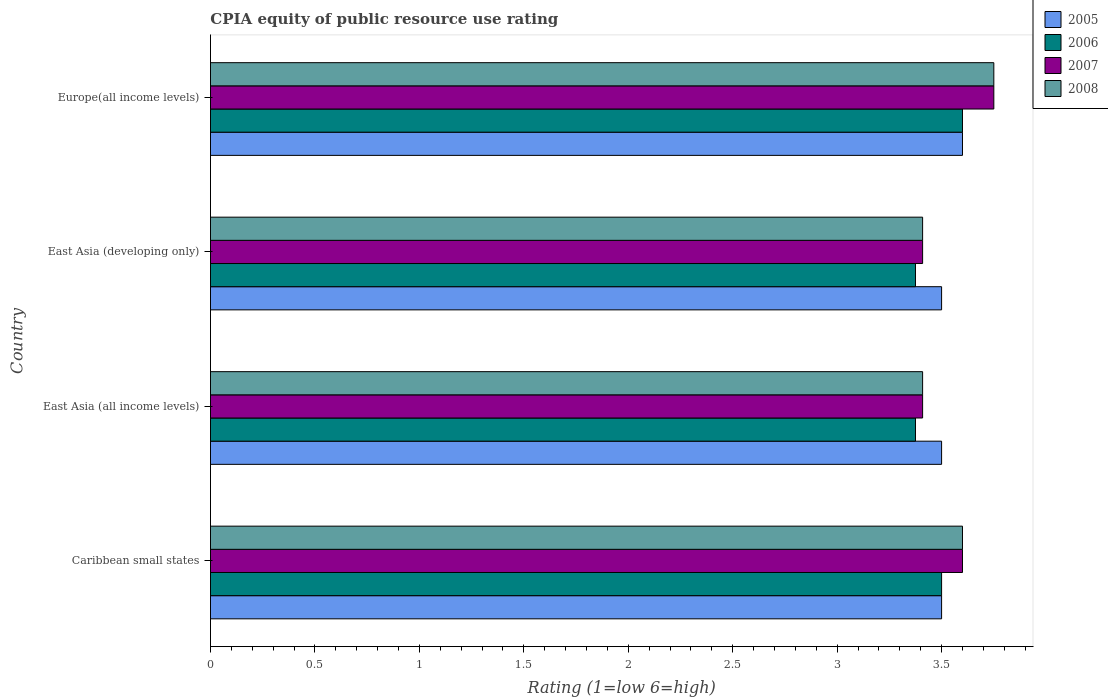How many different coloured bars are there?
Your response must be concise. 4. How many groups of bars are there?
Offer a very short reply. 4. What is the label of the 4th group of bars from the top?
Make the answer very short. Caribbean small states. What is the CPIA rating in 2005 in East Asia (all income levels)?
Your answer should be very brief. 3.5. Across all countries, what is the maximum CPIA rating in 2007?
Your answer should be very brief. 3.75. Across all countries, what is the minimum CPIA rating in 2006?
Offer a very short reply. 3.38. In which country was the CPIA rating in 2008 maximum?
Ensure brevity in your answer.  Europe(all income levels). In which country was the CPIA rating in 2007 minimum?
Make the answer very short. East Asia (all income levels). What is the total CPIA rating in 2008 in the graph?
Your answer should be compact. 14.17. What is the difference between the CPIA rating in 2006 in Caribbean small states and that in East Asia (developing only)?
Make the answer very short. 0.12. What is the difference between the CPIA rating in 2006 in East Asia (developing only) and the CPIA rating in 2007 in East Asia (all income levels)?
Provide a short and direct response. -0.03. What is the average CPIA rating in 2008 per country?
Offer a terse response. 3.54. What is the difference between the CPIA rating in 2007 and CPIA rating in 2008 in Caribbean small states?
Offer a very short reply. 0. What is the ratio of the CPIA rating in 2005 in Caribbean small states to that in Europe(all income levels)?
Make the answer very short. 0.97. What is the difference between the highest and the second highest CPIA rating in 2005?
Provide a short and direct response. 0.1. What is the difference between the highest and the lowest CPIA rating in 2005?
Your answer should be compact. 0.1. In how many countries, is the CPIA rating in 2007 greater than the average CPIA rating in 2007 taken over all countries?
Your answer should be very brief. 2. Is the sum of the CPIA rating in 2008 in East Asia (developing only) and Europe(all income levels) greater than the maximum CPIA rating in 2006 across all countries?
Provide a short and direct response. Yes. How many bars are there?
Offer a very short reply. 16. How many countries are there in the graph?
Make the answer very short. 4. Are the values on the major ticks of X-axis written in scientific E-notation?
Keep it short and to the point. No. Does the graph contain grids?
Ensure brevity in your answer.  No. Where does the legend appear in the graph?
Keep it short and to the point. Top right. How are the legend labels stacked?
Offer a terse response. Vertical. What is the title of the graph?
Offer a terse response. CPIA equity of public resource use rating. What is the label or title of the Y-axis?
Make the answer very short. Country. What is the Rating (1=low 6=high) in 2008 in Caribbean small states?
Your response must be concise. 3.6. What is the Rating (1=low 6=high) of 2006 in East Asia (all income levels)?
Offer a terse response. 3.38. What is the Rating (1=low 6=high) of 2007 in East Asia (all income levels)?
Your response must be concise. 3.41. What is the Rating (1=low 6=high) in 2008 in East Asia (all income levels)?
Provide a short and direct response. 3.41. What is the Rating (1=low 6=high) in 2006 in East Asia (developing only)?
Offer a very short reply. 3.38. What is the Rating (1=low 6=high) in 2007 in East Asia (developing only)?
Provide a short and direct response. 3.41. What is the Rating (1=low 6=high) in 2008 in East Asia (developing only)?
Your response must be concise. 3.41. What is the Rating (1=low 6=high) in 2005 in Europe(all income levels)?
Make the answer very short. 3.6. What is the Rating (1=low 6=high) in 2006 in Europe(all income levels)?
Keep it short and to the point. 3.6. What is the Rating (1=low 6=high) of 2007 in Europe(all income levels)?
Offer a very short reply. 3.75. What is the Rating (1=low 6=high) of 2008 in Europe(all income levels)?
Your answer should be very brief. 3.75. Across all countries, what is the maximum Rating (1=low 6=high) of 2005?
Your answer should be compact. 3.6. Across all countries, what is the maximum Rating (1=low 6=high) in 2007?
Your answer should be very brief. 3.75. Across all countries, what is the maximum Rating (1=low 6=high) in 2008?
Provide a short and direct response. 3.75. Across all countries, what is the minimum Rating (1=low 6=high) in 2006?
Your answer should be compact. 3.38. Across all countries, what is the minimum Rating (1=low 6=high) of 2007?
Your answer should be very brief. 3.41. Across all countries, what is the minimum Rating (1=low 6=high) of 2008?
Your answer should be compact. 3.41. What is the total Rating (1=low 6=high) in 2006 in the graph?
Keep it short and to the point. 13.85. What is the total Rating (1=low 6=high) in 2007 in the graph?
Your answer should be very brief. 14.17. What is the total Rating (1=low 6=high) of 2008 in the graph?
Your answer should be very brief. 14.17. What is the difference between the Rating (1=low 6=high) in 2005 in Caribbean small states and that in East Asia (all income levels)?
Make the answer very short. 0. What is the difference between the Rating (1=low 6=high) of 2007 in Caribbean small states and that in East Asia (all income levels)?
Your response must be concise. 0.19. What is the difference between the Rating (1=low 6=high) of 2008 in Caribbean small states and that in East Asia (all income levels)?
Offer a very short reply. 0.19. What is the difference between the Rating (1=low 6=high) of 2005 in Caribbean small states and that in East Asia (developing only)?
Your answer should be very brief. 0. What is the difference between the Rating (1=low 6=high) of 2007 in Caribbean small states and that in East Asia (developing only)?
Provide a succinct answer. 0.19. What is the difference between the Rating (1=low 6=high) in 2008 in Caribbean small states and that in East Asia (developing only)?
Give a very brief answer. 0.19. What is the difference between the Rating (1=low 6=high) of 2005 in Caribbean small states and that in Europe(all income levels)?
Provide a succinct answer. -0.1. What is the difference between the Rating (1=low 6=high) of 2006 in East Asia (all income levels) and that in East Asia (developing only)?
Keep it short and to the point. 0. What is the difference between the Rating (1=low 6=high) in 2008 in East Asia (all income levels) and that in East Asia (developing only)?
Offer a very short reply. 0. What is the difference between the Rating (1=low 6=high) in 2005 in East Asia (all income levels) and that in Europe(all income levels)?
Offer a very short reply. -0.1. What is the difference between the Rating (1=low 6=high) of 2006 in East Asia (all income levels) and that in Europe(all income levels)?
Keep it short and to the point. -0.23. What is the difference between the Rating (1=low 6=high) of 2007 in East Asia (all income levels) and that in Europe(all income levels)?
Your answer should be compact. -0.34. What is the difference between the Rating (1=low 6=high) of 2008 in East Asia (all income levels) and that in Europe(all income levels)?
Ensure brevity in your answer.  -0.34. What is the difference between the Rating (1=low 6=high) of 2006 in East Asia (developing only) and that in Europe(all income levels)?
Make the answer very short. -0.23. What is the difference between the Rating (1=low 6=high) in 2007 in East Asia (developing only) and that in Europe(all income levels)?
Offer a very short reply. -0.34. What is the difference between the Rating (1=low 6=high) in 2008 in East Asia (developing only) and that in Europe(all income levels)?
Your response must be concise. -0.34. What is the difference between the Rating (1=low 6=high) in 2005 in Caribbean small states and the Rating (1=low 6=high) in 2006 in East Asia (all income levels)?
Make the answer very short. 0.12. What is the difference between the Rating (1=low 6=high) in 2005 in Caribbean small states and the Rating (1=low 6=high) in 2007 in East Asia (all income levels)?
Your answer should be compact. 0.09. What is the difference between the Rating (1=low 6=high) of 2005 in Caribbean small states and the Rating (1=low 6=high) of 2008 in East Asia (all income levels)?
Your answer should be compact. 0.09. What is the difference between the Rating (1=low 6=high) of 2006 in Caribbean small states and the Rating (1=low 6=high) of 2007 in East Asia (all income levels)?
Offer a terse response. 0.09. What is the difference between the Rating (1=low 6=high) in 2006 in Caribbean small states and the Rating (1=low 6=high) in 2008 in East Asia (all income levels)?
Your answer should be very brief. 0.09. What is the difference between the Rating (1=low 6=high) of 2007 in Caribbean small states and the Rating (1=low 6=high) of 2008 in East Asia (all income levels)?
Provide a succinct answer. 0.19. What is the difference between the Rating (1=low 6=high) of 2005 in Caribbean small states and the Rating (1=low 6=high) of 2007 in East Asia (developing only)?
Keep it short and to the point. 0.09. What is the difference between the Rating (1=low 6=high) of 2005 in Caribbean small states and the Rating (1=low 6=high) of 2008 in East Asia (developing only)?
Ensure brevity in your answer.  0.09. What is the difference between the Rating (1=low 6=high) in 2006 in Caribbean small states and the Rating (1=low 6=high) in 2007 in East Asia (developing only)?
Your answer should be compact. 0.09. What is the difference between the Rating (1=low 6=high) of 2006 in Caribbean small states and the Rating (1=low 6=high) of 2008 in East Asia (developing only)?
Your answer should be compact. 0.09. What is the difference between the Rating (1=low 6=high) of 2007 in Caribbean small states and the Rating (1=low 6=high) of 2008 in East Asia (developing only)?
Provide a succinct answer. 0.19. What is the difference between the Rating (1=low 6=high) in 2005 in Caribbean small states and the Rating (1=low 6=high) in 2007 in Europe(all income levels)?
Your answer should be very brief. -0.25. What is the difference between the Rating (1=low 6=high) in 2005 in Caribbean small states and the Rating (1=low 6=high) in 2008 in Europe(all income levels)?
Provide a succinct answer. -0.25. What is the difference between the Rating (1=low 6=high) in 2006 in Caribbean small states and the Rating (1=low 6=high) in 2007 in Europe(all income levels)?
Give a very brief answer. -0.25. What is the difference between the Rating (1=low 6=high) of 2006 in Caribbean small states and the Rating (1=low 6=high) of 2008 in Europe(all income levels)?
Keep it short and to the point. -0.25. What is the difference between the Rating (1=low 6=high) of 2005 in East Asia (all income levels) and the Rating (1=low 6=high) of 2006 in East Asia (developing only)?
Your answer should be compact. 0.12. What is the difference between the Rating (1=low 6=high) of 2005 in East Asia (all income levels) and the Rating (1=low 6=high) of 2007 in East Asia (developing only)?
Give a very brief answer. 0.09. What is the difference between the Rating (1=low 6=high) of 2005 in East Asia (all income levels) and the Rating (1=low 6=high) of 2008 in East Asia (developing only)?
Your response must be concise. 0.09. What is the difference between the Rating (1=low 6=high) in 2006 in East Asia (all income levels) and the Rating (1=low 6=high) in 2007 in East Asia (developing only)?
Ensure brevity in your answer.  -0.03. What is the difference between the Rating (1=low 6=high) of 2006 in East Asia (all income levels) and the Rating (1=low 6=high) of 2008 in East Asia (developing only)?
Offer a terse response. -0.03. What is the difference between the Rating (1=low 6=high) in 2005 in East Asia (all income levels) and the Rating (1=low 6=high) in 2006 in Europe(all income levels)?
Provide a short and direct response. -0.1. What is the difference between the Rating (1=low 6=high) in 2005 in East Asia (all income levels) and the Rating (1=low 6=high) in 2008 in Europe(all income levels)?
Make the answer very short. -0.25. What is the difference between the Rating (1=low 6=high) of 2006 in East Asia (all income levels) and the Rating (1=low 6=high) of 2007 in Europe(all income levels)?
Your response must be concise. -0.38. What is the difference between the Rating (1=low 6=high) in 2006 in East Asia (all income levels) and the Rating (1=low 6=high) in 2008 in Europe(all income levels)?
Give a very brief answer. -0.38. What is the difference between the Rating (1=low 6=high) in 2007 in East Asia (all income levels) and the Rating (1=low 6=high) in 2008 in Europe(all income levels)?
Make the answer very short. -0.34. What is the difference between the Rating (1=low 6=high) in 2005 in East Asia (developing only) and the Rating (1=low 6=high) in 2006 in Europe(all income levels)?
Provide a succinct answer. -0.1. What is the difference between the Rating (1=low 6=high) in 2005 in East Asia (developing only) and the Rating (1=low 6=high) in 2008 in Europe(all income levels)?
Offer a very short reply. -0.25. What is the difference between the Rating (1=low 6=high) in 2006 in East Asia (developing only) and the Rating (1=low 6=high) in 2007 in Europe(all income levels)?
Keep it short and to the point. -0.38. What is the difference between the Rating (1=low 6=high) in 2006 in East Asia (developing only) and the Rating (1=low 6=high) in 2008 in Europe(all income levels)?
Ensure brevity in your answer.  -0.38. What is the difference between the Rating (1=low 6=high) of 2007 in East Asia (developing only) and the Rating (1=low 6=high) of 2008 in Europe(all income levels)?
Offer a very short reply. -0.34. What is the average Rating (1=low 6=high) in 2005 per country?
Offer a terse response. 3.52. What is the average Rating (1=low 6=high) in 2006 per country?
Offer a very short reply. 3.46. What is the average Rating (1=low 6=high) in 2007 per country?
Keep it short and to the point. 3.54. What is the average Rating (1=low 6=high) of 2008 per country?
Your response must be concise. 3.54. What is the difference between the Rating (1=low 6=high) of 2005 and Rating (1=low 6=high) of 2006 in Caribbean small states?
Your response must be concise. 0. What is the difference between the Rating (1=low 6=high) of 2005 and Rating (1=low 6=high) of 2007 in Caribbean small states?
Provide a succinct answer. -0.1. What is the difference between the Rating (1=low 6=high) in 2005 and Rating (1=low 6=high) in 2008 in Caribbean small states?
Provide a succinct answer. -0.1. What is the difference between the Rating (1=low 6=high) of 2006 and Rating (1=low 6=high) of 2008 in Caribbean small states?
Give a very brief answer. -0.1. What is the difference between the Rating (1=low 6=high) in 2007 and Rating (1=low 6=high) in 2008 in Caribbean small states?
Offer a very short reply. 0. What is the difference between the Rating (1=low 6=high) in 2005 and Rating (1=low 6=high) in 2006 in East Asia (all income levels)?
Make the answer very short. 0.12. What is the difference between the Rating (1=low 6=high) in 2005 and Rating (1=low 6=high) in 2007 in East Asia (all income levels)?
Your answer should be compact. 0.09. What is the difference between the Rating (1=low 6=high) of 2005 and Rating (1=low 6=high) of 2008 in East Asia (all income levels)?
Your answer should be compact. 0.09. What is the difference between the Rating (1=low 6=high) in 2006 and Rating (1=low 6=high) in 2007 in East Asia (all income levels)?
Your answer should be compact. -0.03. What is the difference between the Rating (1=low 6=high) in 2006 and Rating (1=low 6=high) in 2008 in East Asia (all income levels)?
Your response must be concise. -0.03. What is the difference between the Rating (1=low 6=high) of 2005 and Rating (1=low 6=high) of 2006 in East Asia (developing only)?
Keep it short and to the point. 0.12. What is the difference between the Rating (1=low 6=high) of 2005 and Rating (1=low 6=high) of 2007 in East Asia (developing only)?
Provide a succinct answer. 0.09. What is the difference between the Rating (1=low 6=high) of 2005 and Rating (1=low 6=high) of 2008 in East Asia (developing only)?
Your answer should be compact. 0.09. What is the difference between the Rating (1=low 6=high) in 2006 and Rating (1=low 6=high) in 2007 in East Asia (developing only)?
Offer a terse response. -0.03. What is the difference between the Rating (1=low 6=high) in 2006 and Rating (1=low 6=high) in 2008 in East Asia (developing only)?
Your answer should be very brief. -0.03. What is the difference between the Rating (1=low 6=high) in 2007 and Rating (1=low 6=high) in 2008 in East Asia (developing only)?
Give a very brief answer. 0. What is the difference between the Rating (1=low 6=high) of 2005 and Rating (1=low 6=high) of 2007 in Europe(all income levels)?
Your answer should be compact. -0.15. What is the difference between the Rating (1=low 6=high) in 2005 and Rating (1=low 6=high) in 2008 in Europe(all income levels)?
Your response must be concise. -0.15. What is the ratio of the Rating (1=low 6=high) in 2005 in Caribbean small states to that in East Asia (all income levels)?
Keep it short and to the point. 1. What is the ratio of the Rating (1=low 6=high) of 2006 in Caribbean small states to that in East Asia (all income levels)?
Offer a very short reply. 1.04. What is the ratio of the Rating (1=low 6=high) of 2007 in Caribbean small states to that in East Asia (all income levels)?
Keep it short and to the point. 1.06. What is the ratio of the Rating (1=low 6=high) of 2008 in Caribbean small states to that in East Asia (all income levels)?
Give a very brief answer. 1.06. What is the ratio of the Rating (1=low 6=high) in 2007 in Caribbean small states to that in East Asia (developing only)?
Offer a terse response. 1.06. What is the ratio of the Rating (1=low 6=high) of 2008 in Caribbean small states to that in East Asia (developing only)?
Provide a succinct answer. 1.06. What is the ratio of the Rating (1=low 6=high) in 2005 in Caribbean small states to that in Europe(all income levels)?
Your answer should be compact. 0.97. What is the ratio of the Rating (1=low 6=high) of 2006 in Caribbean small states to that in Europe(all income levels)?
Offer a terse response. 0.97. What is the ratio of the Rating (1=low 6=high) in 2007 in Caribbean small states to that in Europe(all income levels)?
Provide a succinct answer. 0.96. What is the ratio of the Rating (1=low 6=high) of 2005 in East Asia (all income levels) to that in Europe(all income levels)?
Provide a short and direct response. 0.97. What is the ratio of the Rating (1=low 6=high) of 2006 in East Asia (all income levels) to that in Europe(all income levels)?
Give a very brief answer. 0.94. What is the ratio of the Rating (1=low 6=high) in 2007 in East Asia (all income levels) to that in Europe(all income levels)?
Make the answer very short. 0.91. What is the ratio of the Rating (1=low 6=high) in 2008 in East Asia (all income levels) to that in Europe(all income levels)?
Make the answer very short. 0.91. What is the ratio of the Rating (1=low 6=high) of 2005 in East Asia (developing only) to that in Europe(all income levels)?
Offer a very short reply. 0.97. What is the ratio of the Rating (1=low 6=high) in 2006 in East Asia (developing only) to that in Europe(all income levels)?
Offer a terse response. 0.94. What is the difference between the highest and the second highest Rating (1=low 6=high) of 2005?
Provide a short and direct response. 0.1. What is the difference between the highest and the second highest Rating (1=low 6=high) of 2007?
Give a very brief answer. 0.15. What is the difference between the highest and the lowest Rating (1=low 6=high) in 2005?
Provide a short and direct response. 0.1. What is the difference between the highest and the lowest Rating (1=low 6=high) of 2006?
Your answer should be compact. 0.23. What is the difference between the highest and the lowest Rating (1=low 6=high) in 2007?
Keep it short and to the point. 0.34. What is the difference between the highest and the lowest Rating (1=low 6=high) of 2008?
Offer a terse response. 0.34. 